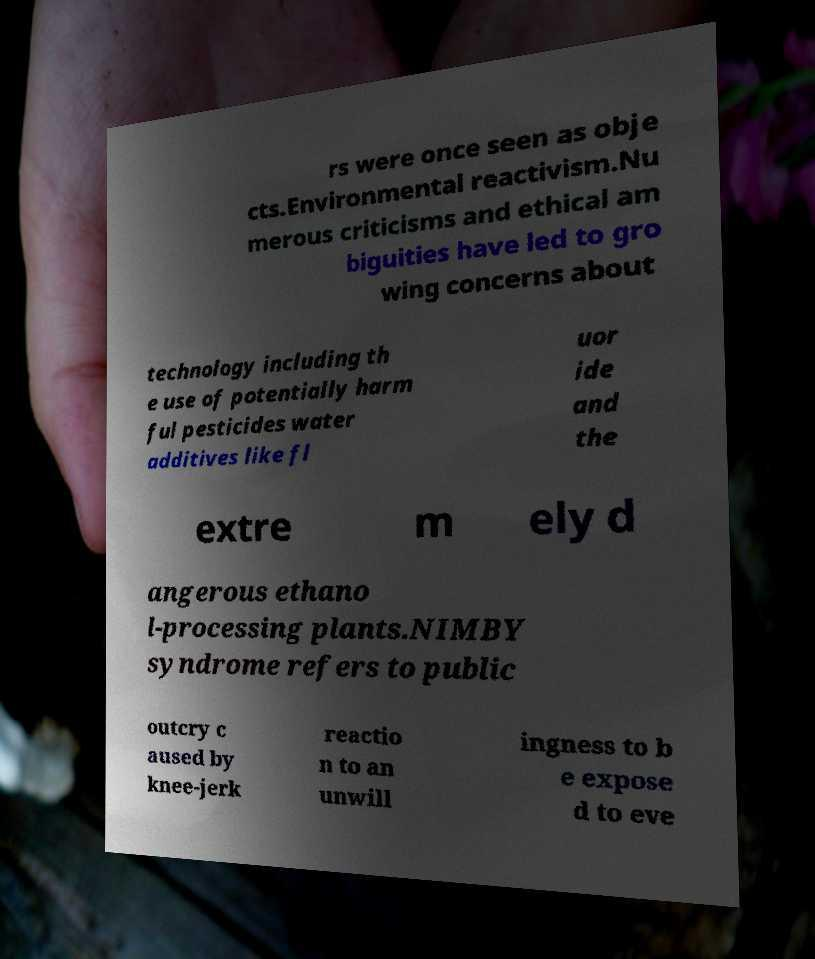Please identify and transcribe the text found in this image. rs were once seen as obje cts.Environmental reactivism.Nu merous criticisms and ethical am biguities have led to gro wing concerns about technology including th e use of potentially harm ful pesticides water additives like fl uor ide and the extre m ely d angerous ethano l-processing plants.NIMBY syndrome refers to public outcry c aused by knee-jerk reactio n to an unwill ingness to b e expose d to eve 